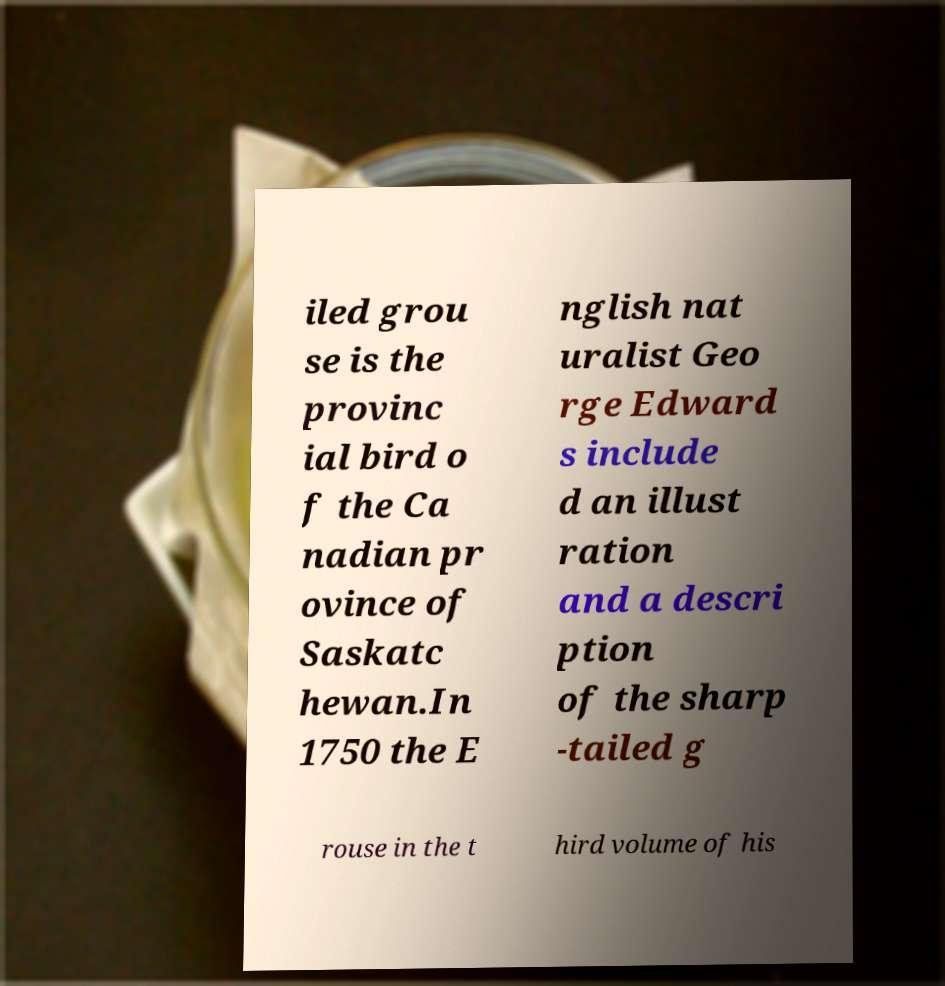Please identify and transcribe the text found in this image. iled grou se is the provinc ial bird o f the Ca nadian pr ovince of Saskatc hewan.In 1750 the E nglish nat uralist Geo rge Edward s include d an illust ration and a descri ption of the sharp -tailed g rouse in the t hird volume of his 